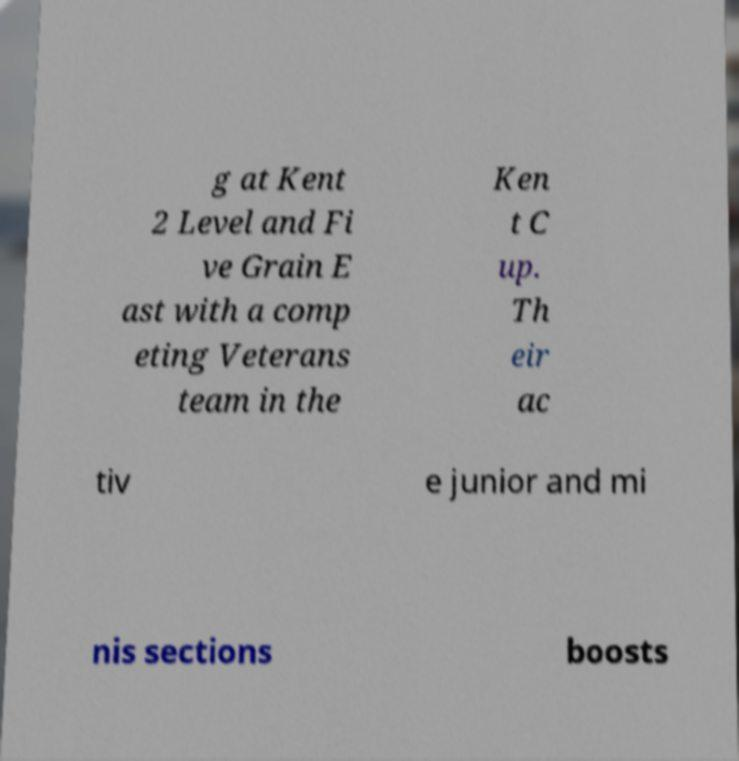There's text embedded in this image that I need extracted. Can you transcribe it verbatim? g at Kent 2 Level and Fi ve Grain E ast with a comp eting Veterans team in the Ken t C up. Th eir ac tiv e junior and mi nis sections boosts 